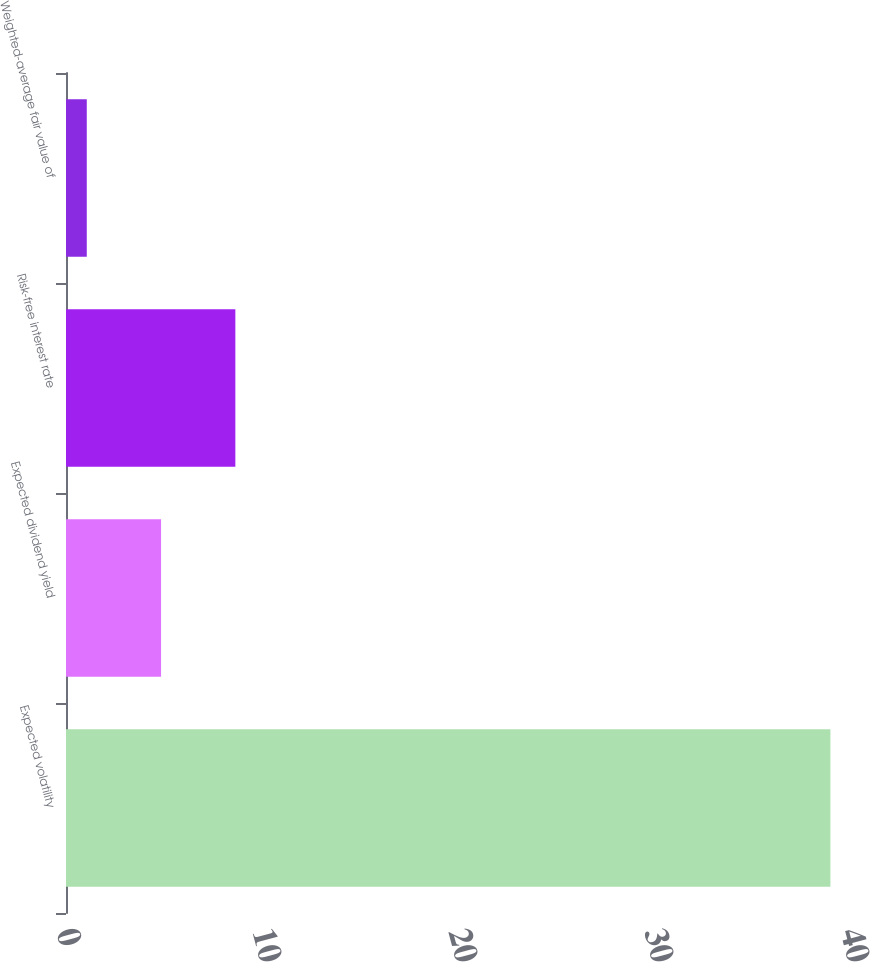Convert chart to OTSL. <chart><loc_0><loc_0><loc_500><loc_500><bar_chart><fcel>Expected volatility<fcel>Expected dividend yield<fcel>Risk-free interest rate<fcel>Weighted-average fair value of<nl><fcel>39<fcel>4.85<fcel>8.64<fcel>1.06<nl></chart> 